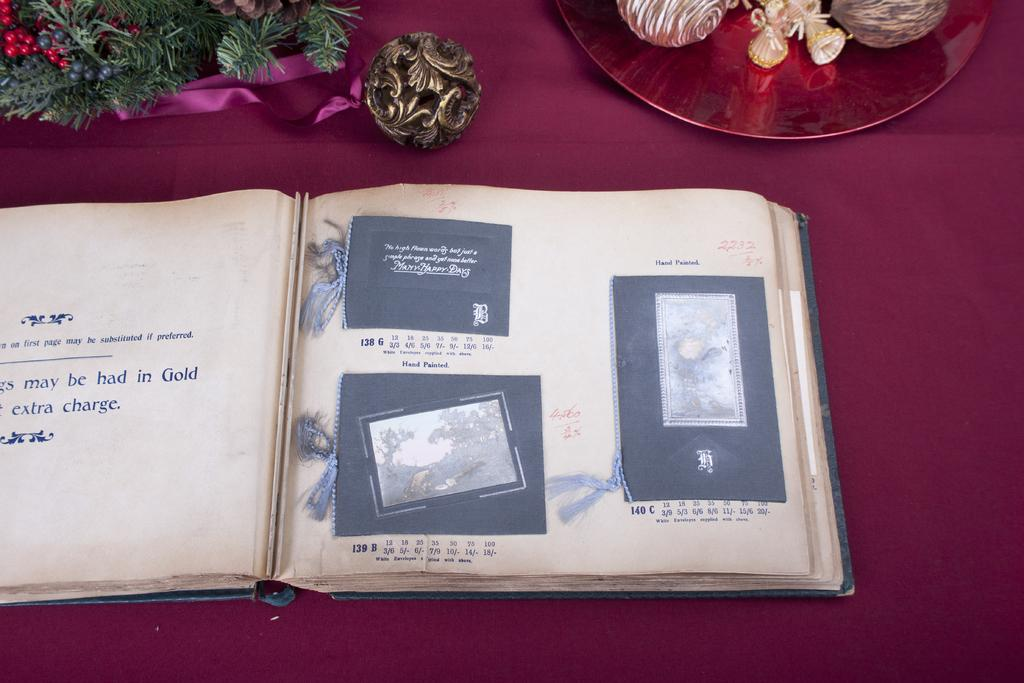<image>
Provide a brief description of the given image. a photo album open to pages that say Hand Painted 